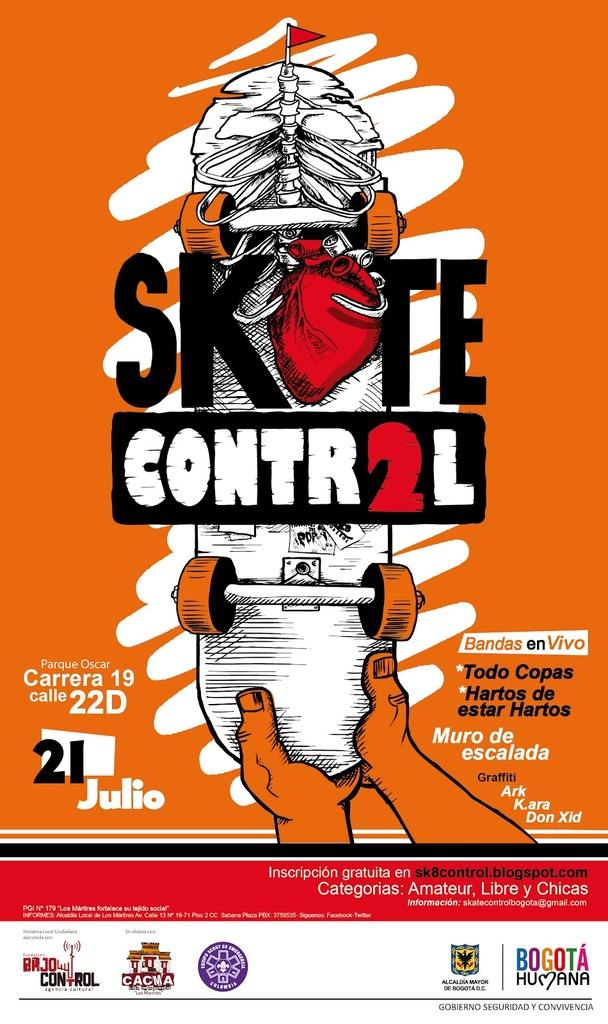<image>
Create a compact narrative representing the image presented. A flyer showing a person holding a skate board advertising for Skate Control. 